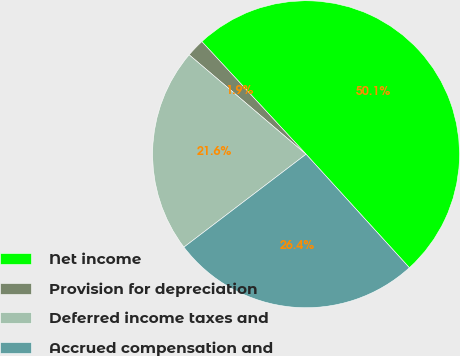<chart> <loc_0><loc_0><loc_500><loc_500><pie_chart><fcel>Net income<fcel>Provision for depreciation<fcel>Deferred income taxes and<fcel>Accrued compensation and<nl><fcel>50.13%<fcel>1.9%<fcel>21.57%<fcel>26.4%<nl></chart> 